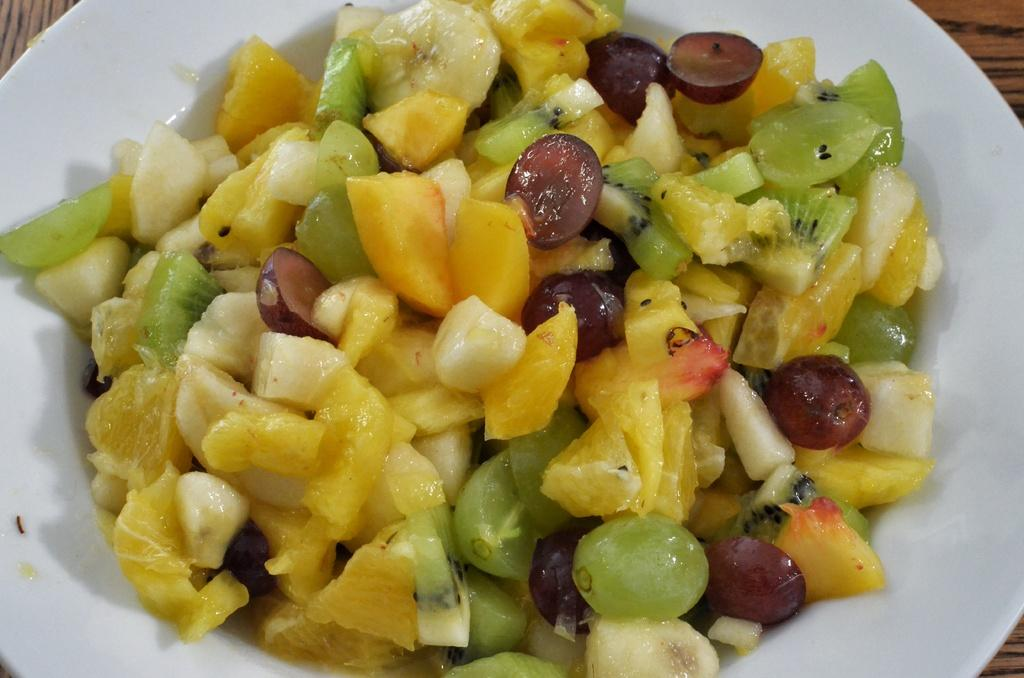What type of food is in the bowl in the image? There is a fruit salad in the bowl in the image. Where is the bowl with the fruit salad located? The bowl is placed on a table. What type of clock is hanging on the shelf above the fruit salad in the image? There is no clock or shelf present in the image; it only features a bowl of fruit salad on a table. 